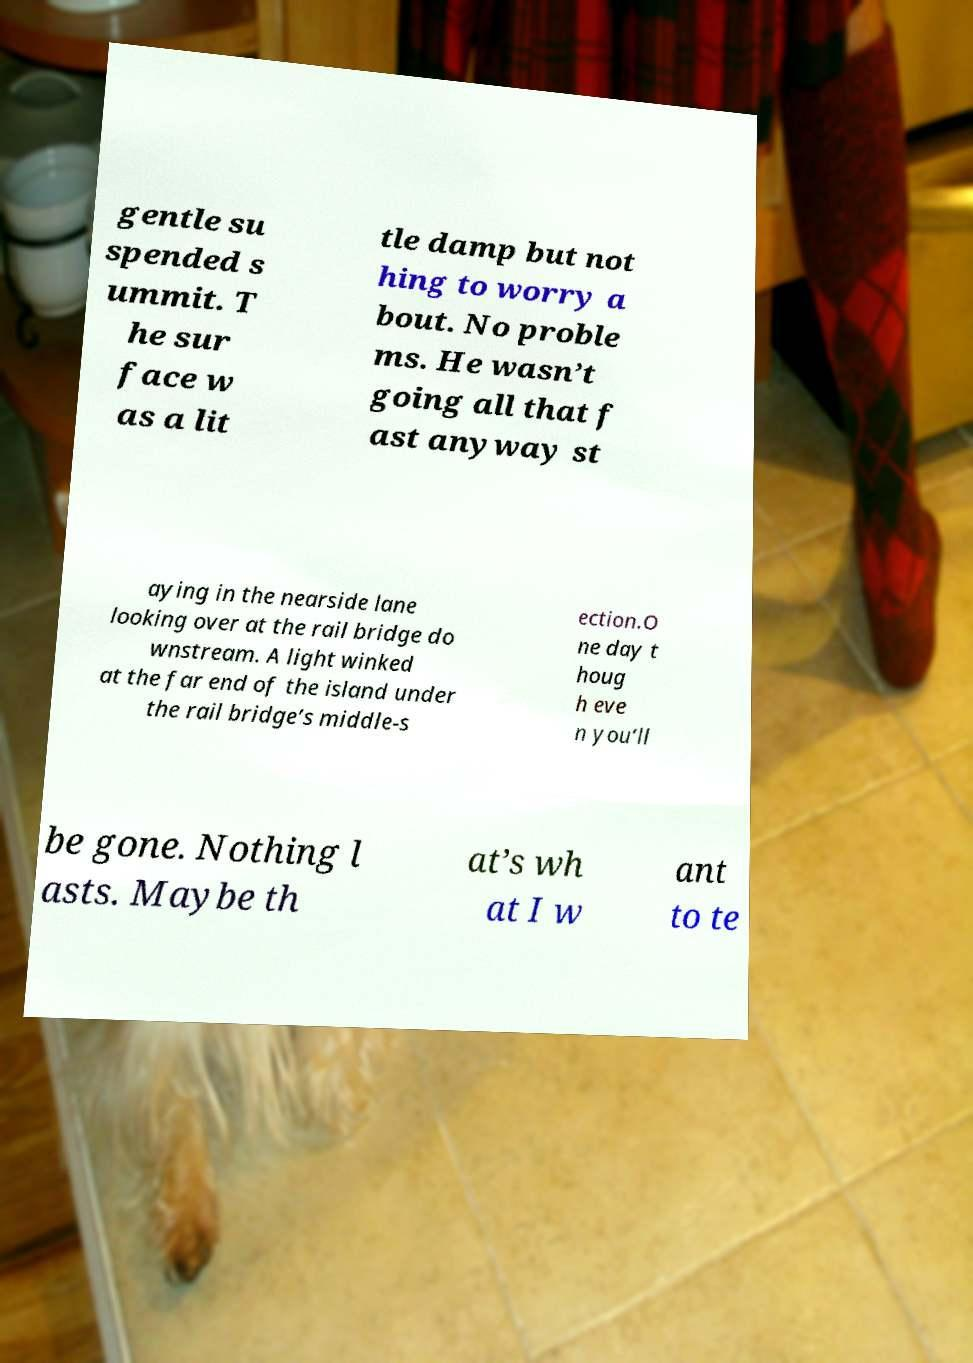For documentation purposes, I need the text within this image transcribed. Could you provide that? gentle su spended s ummit. T he sur face w as a lit tle damp but not hing to worry a bout. No proble ms. He wasn’t going all that f ast anyway st aying in the nearside lane looking over at the rail bridge do wnstream. A light winked at the far end of the island under the rail bridge’s middle-s ection.O ne day t houg h eve n you’ll be gone. Nothing l asts. Maybe th at’s wh at I w ant to te 